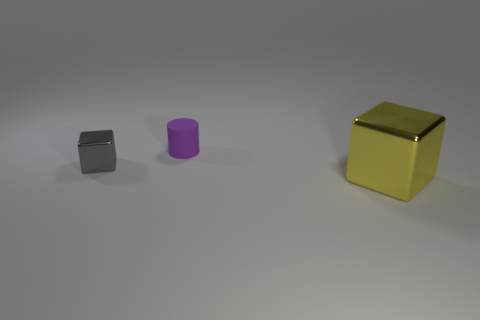What color is the cube that is in front of the shiny cube that is left of the big shiny thing that is to the right of the purple thing?
Ensure brevity in your answer.  Yellow. What shape is the big shiny object?
Offer a terse response. Cube. Is the number of large objects that are in front of the big yellow metallic cube the same as the number of blue metallic cylinders?
Give a very brief answer. Yes. How many brown metallic spheres are the same size as the rubber thing?
Offer a very short reply. 0. Are there any big brown metallic spheres?
Your response must be concise. No. There is a metallic object that is to the right of the purple matte object; is it the same shape as the small object behind the gray cube?
Ensure brevity in your answer.  No. What number of large objects are cyan cubes or purple matte cylinders?
Give a very brief answer. 0. What is the shape of the thing that is the same material as the big block?
Give a very brief answer. Cube. Does the gray thing have the same shape as the purple thing?
Your response must be concise. No. The tiny rubber cylinder has what color?
Your response must be concise. Purple. 